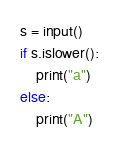Convert code to text. <code><loc_0><loc_0><loc_500><loc_500><_Python_>s = input()
if s.islower():
    print("a")
else:
    print("A")
</code> 